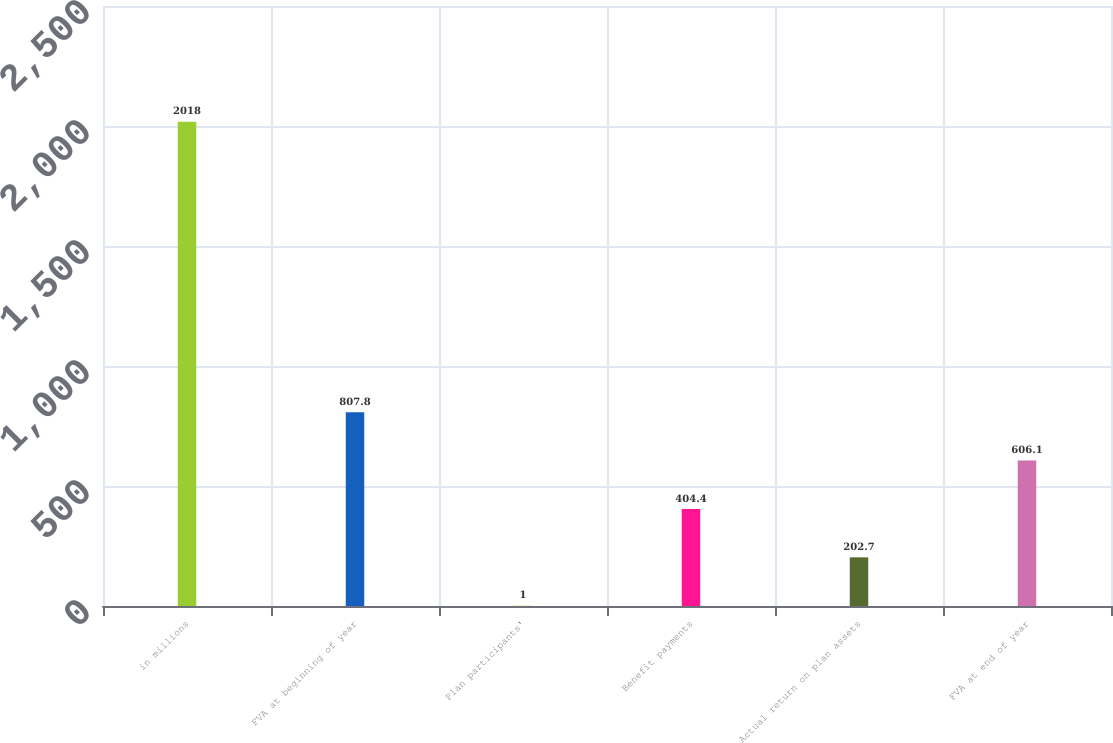Convert chart to OTSL. <chart><loc_0><loc_0><loc_500><loc_500><bar_chart><fcel>in millions<fcel>FVA at beginning of year<fcel>Plan participants'<fcel>Benefit payments<fcel>Actual return on plan assets<fcel>FVA at end of year<nl><fcel>2018<fcel>807.8<fcel>1<fcel>404.4<fcel>202.7<fcel>606.1<nl></chart> 